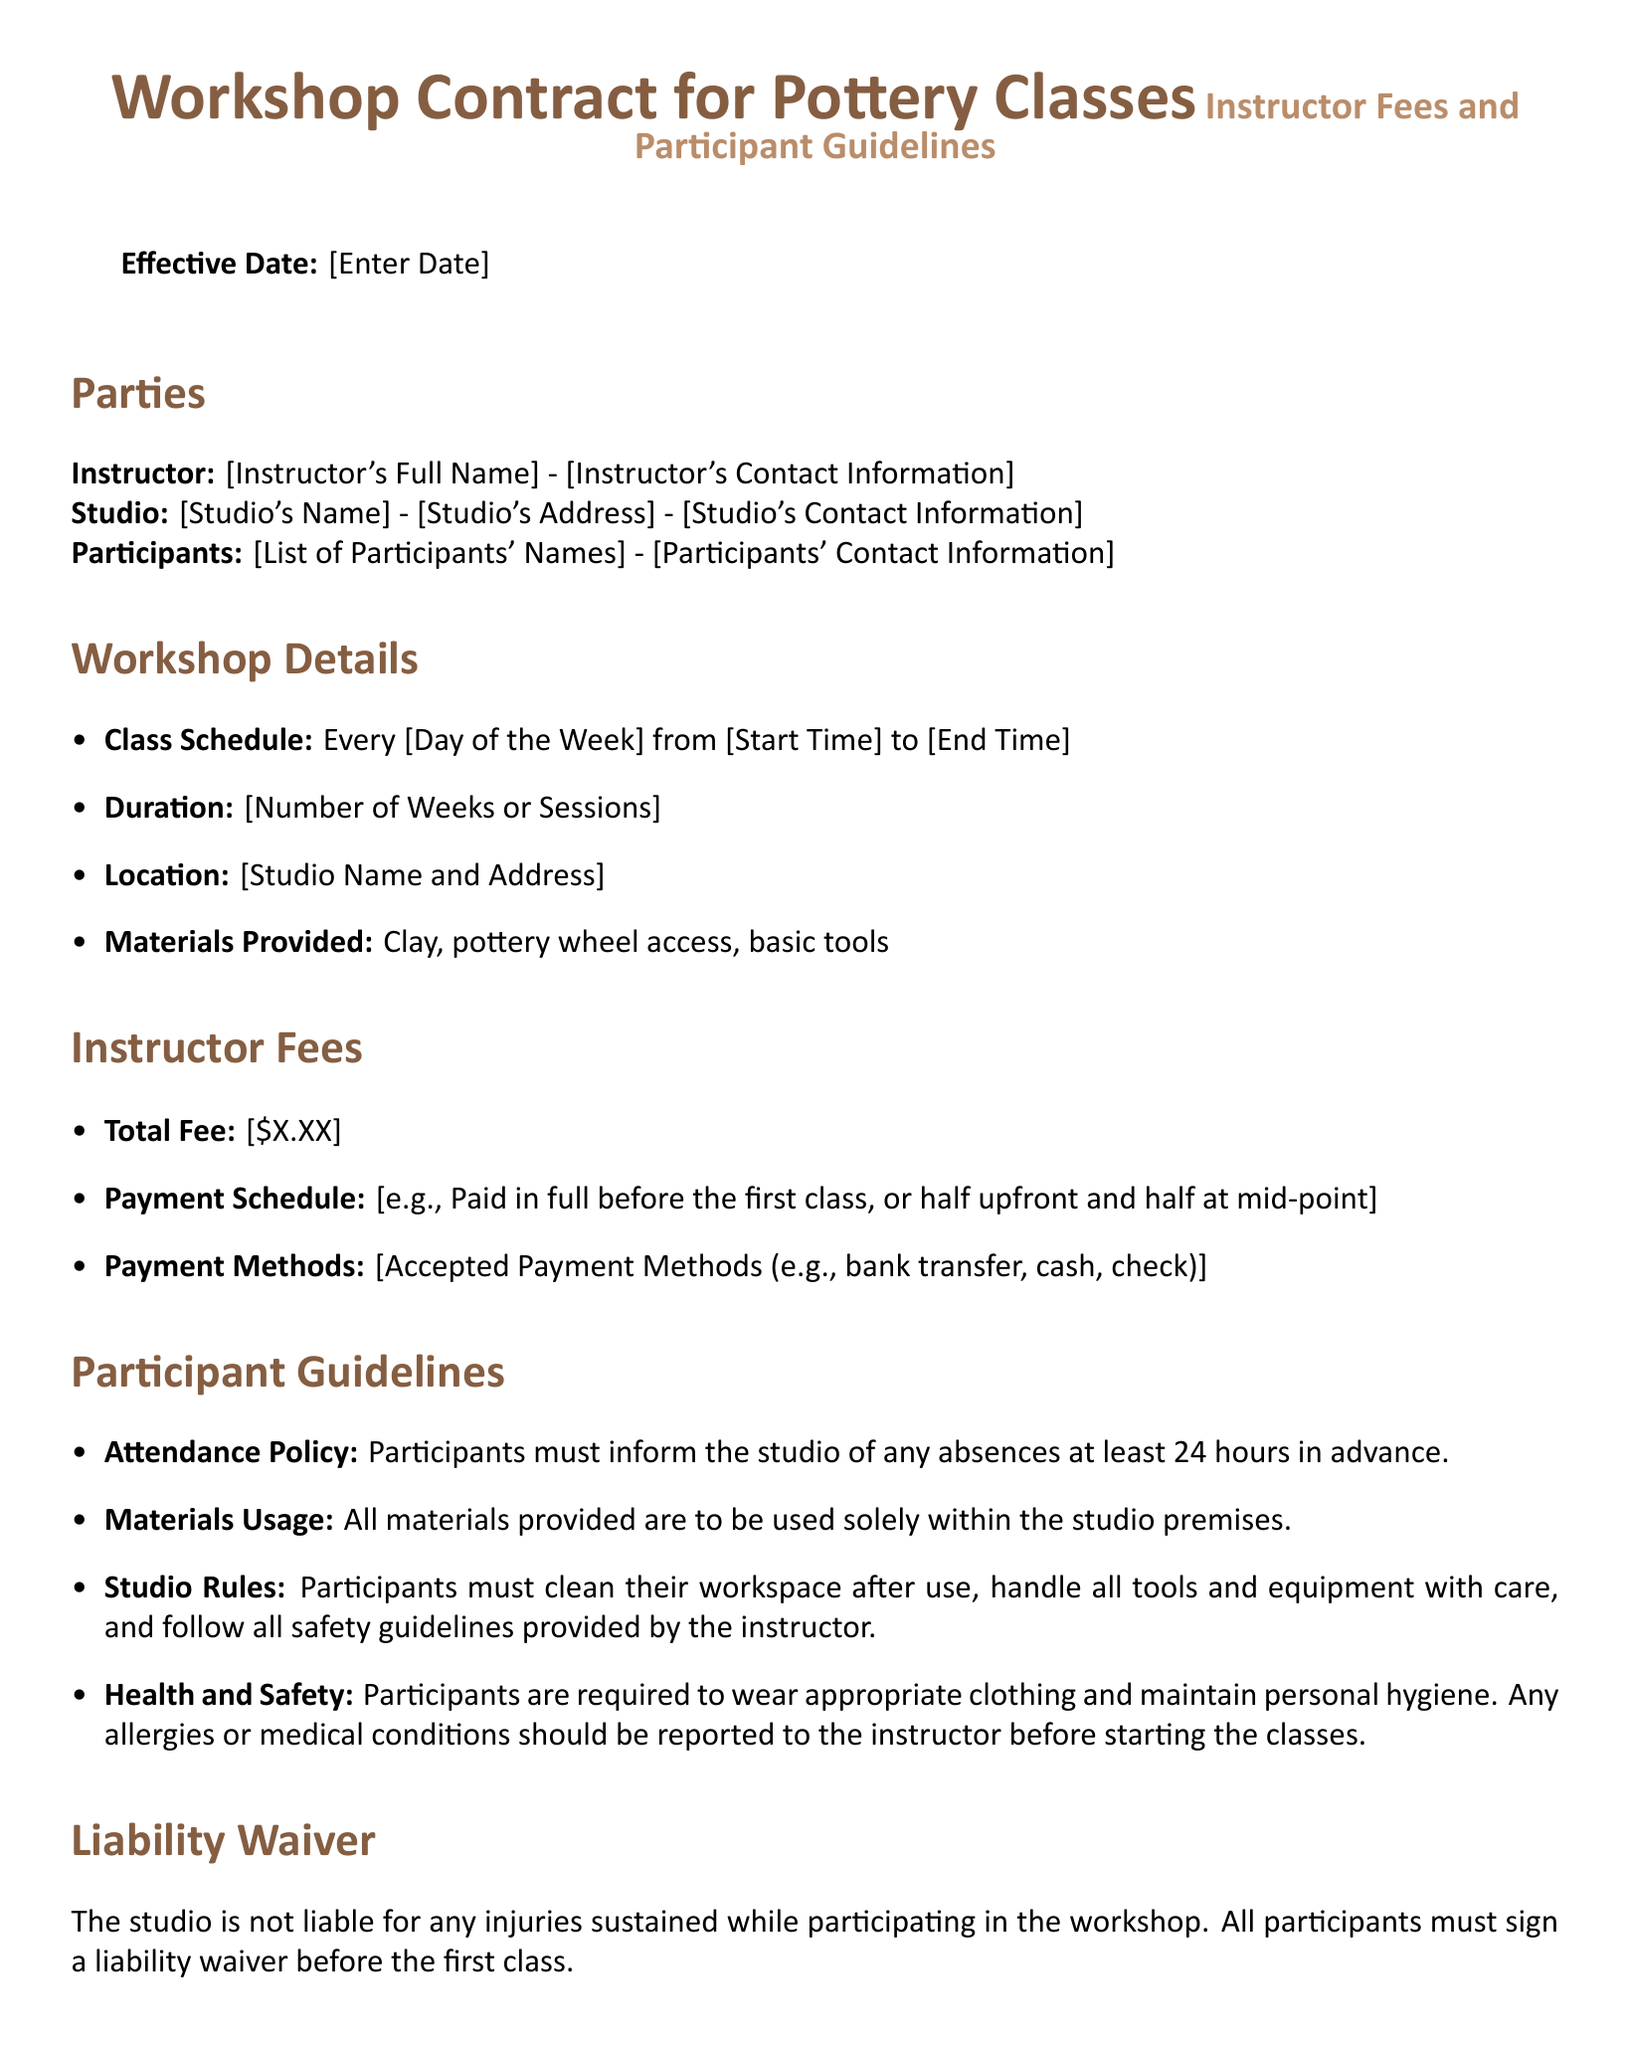What is the effective date? The effective date is the date when the contract starts, which is specified as "[Enter Date]".
Answer: [Enter Date] What is the class schedule? The class schedule specifies the days and times of the pottery classes, indicated as "Every [Day of the Week] from [Start Time] to [End Time]".
Answer: Every [Day of the Week] from [Start Time] to [End Time] What is the total fee for the workshop? The total fee for the workshop is mentioned as "[\$X.XX]".
Answer: [$X.XX] What is the attendance policy? The attendance policy states that participants must inform the studio of any absences at least 24 hours in advance.
Answer: Inform the studio of any absences at least 24 hours in advance What happens if a participant cancels within 48 hours of the start date? The cancellation policy indicates that no refunds are available if canceled within 48 hours of the start date.
Answer: No refunds available What should participants wear during the workshop? The health and safety section requires participants to wear appropriate clothing.
Answer: Appropriate clothing How many weeks or sessions does the workshop last? The duration of the workshop is defined as "[Number of Weeks or Sessions]".
Answer: [Number of Weeks or Sessions] What must all participants sign before the first class? The liability waiver must be signed by all participants before the first class.
Answer: Liability waiver Who needs to sign the contract? The contract requires the signatures of the instructor, studio representative, and the participant.
Answer: Instructor, studio representative, and participant 